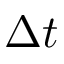Convert formula to latex. <formula><loc_0><loc_0><loc_500><loc_500>\Delta t</formula> 